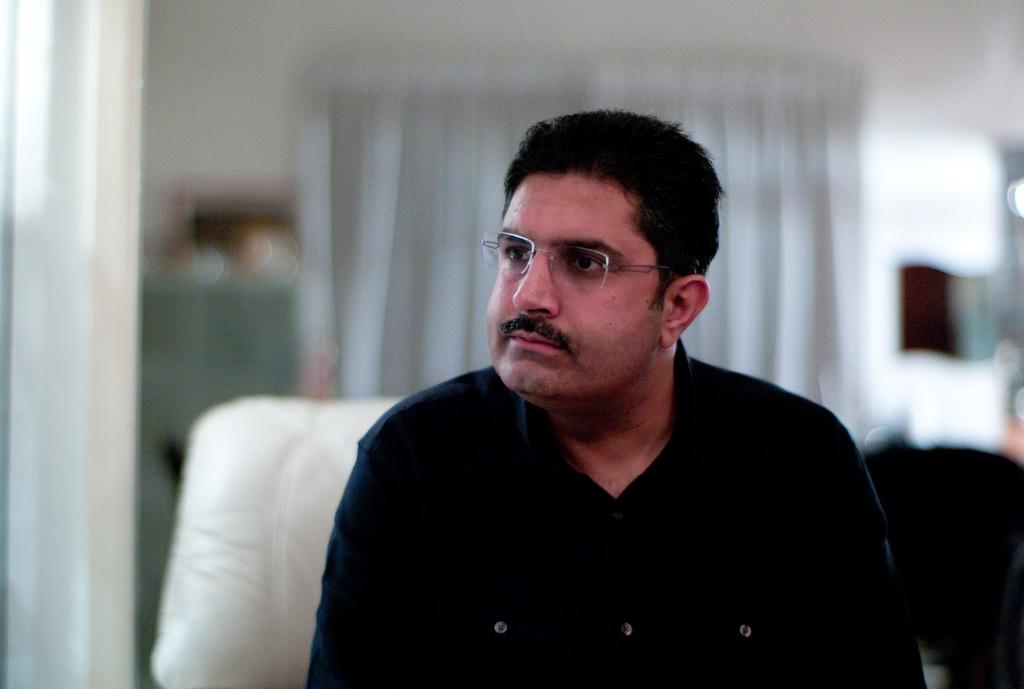Who is the main subject in the image? There is a man in the center of the image. What is the man doing in the image? The man is sitting on a sofa. What can be seen in the background of the image? There are curtains in the background of the image. How would you describe the background of the image? The background of the image is blurred. What type of berry is being served on the channel in the image? There is no berry or channel present in the image. Who is the owner of the sofa in the image? The image does not provide information about the ownership of the sofa. 